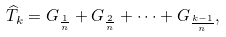Convert formula to latex. <formula><loc_0><loc_0><loc_500><loc_500>\widehat { T } _ { k } = G _ { \frac { 1 } { n } } + G _ { \frac { 2 } { n } } + \cdots + G _ { \frac { k - 1 } { n } } ,</formula> 